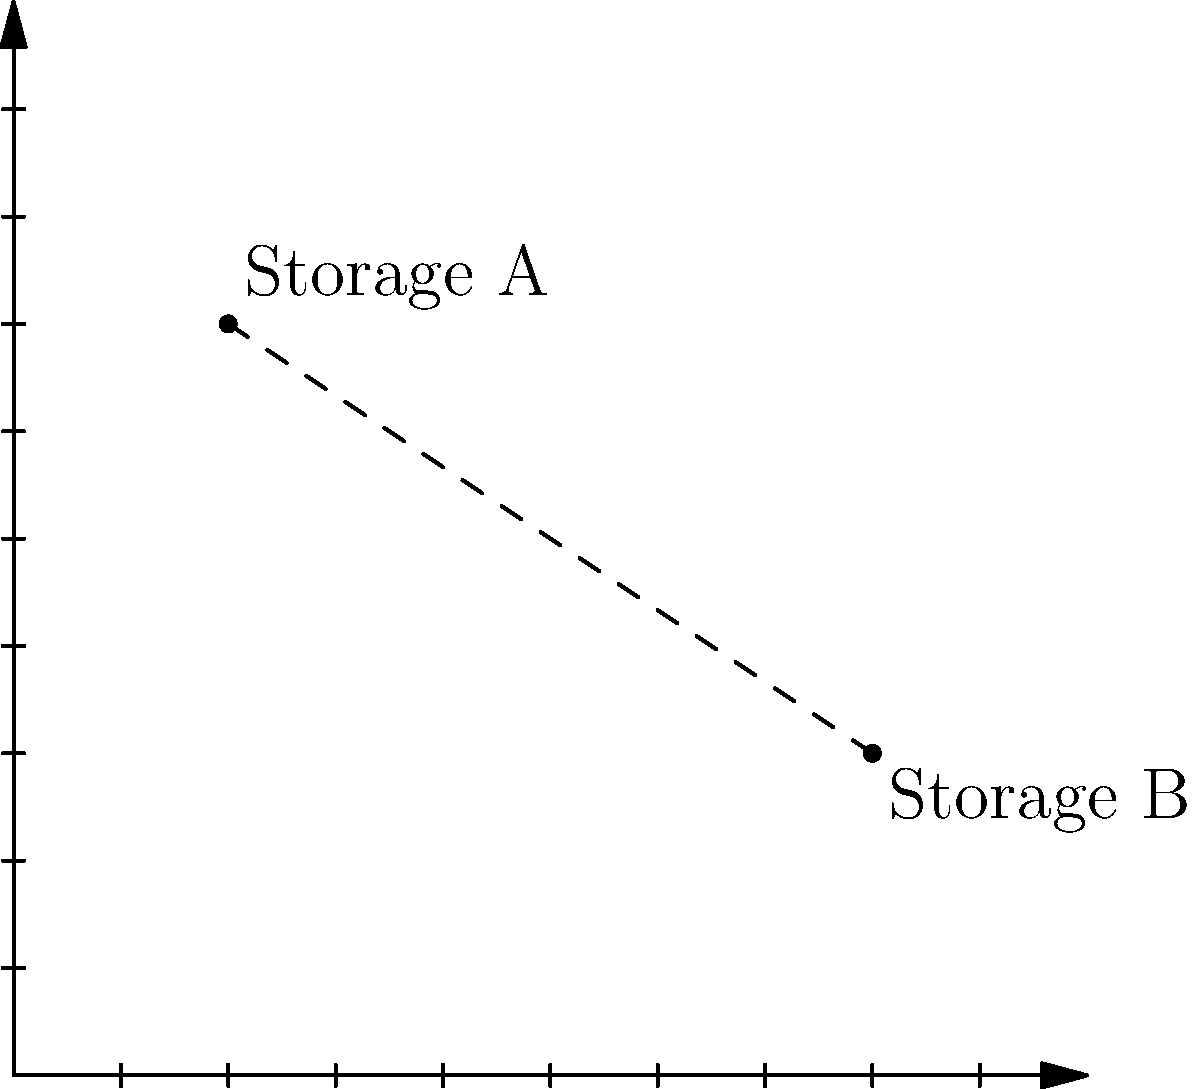As a senior medical representative, you're tasked with optimizing drug storage locations. Two storage facilities, A and B, are represented on a coordinate plane where each unit represents 100 meters. Storage A is located at (2, 7) and Storage B is at (8, 3). Calculate the straight-line distance between these two storage locations to determine the most efficient route for drug transportation. To find the distance between two points, we can use the distance formula derived from the Pythagorean theorem:

$d = \sqrt{(x_2 - x_1)^2 + (y_2 - y_1)^2}$

Where $(x_1, y_1)$ represents the coordinates of the first point and $(x_2, y_2)$ represents the coordinates of the second point.

Given:
- Storage A: $(x_1, y_1) = (2, 7)$
- Storage B: $(x_2, y_2) = (8, 3)$

Let's substitute these values into the formula:

$d = \sqrt{(8 - 2)^2 + (3 - 7)^2}$

Simplify:
$d = \sqrt{6^2 + (-4)^2}$

Calculate the squares:
$d = \sqrt{36 + 16}$

Add under the square root:
$d = \sqrt{52}$

Simplify the square root:
$d = 2\sqrt{13}$

Remember that each unit represents 100 meters, so the actual distance is:

$\text{Actual distance} = 2\sqrt{13} \times 100 \text{ meters}$

$\text{Actual distance} = 200\sqrt{13} \text{ meters}$

This is approximately 721.11 meters.
Answer: $200\sqrt{13}$ meters 